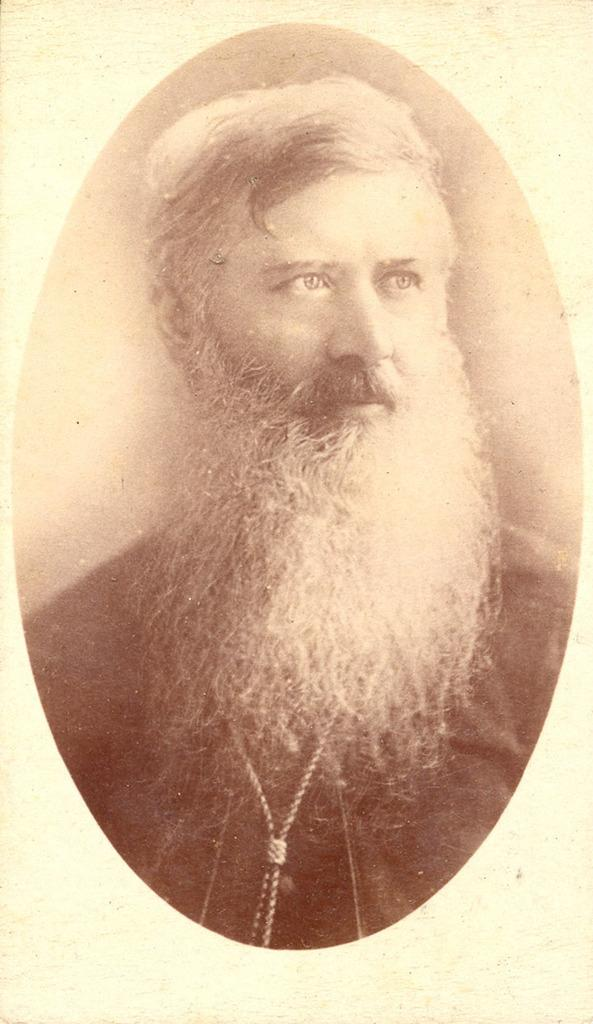What is the main subject of the image? There is a photo of a man in the image. Can you describe the man in the photo? Unfortunately, the provided facts do not include any details about the man's appearance or clothing. What might the man be doing in the photo? Without additional context or information, it is impossible to determine what the man is doing in the photo. What type of underwear is the man wearing in the photo? There is no information about the man's clothing, including any underwear. 